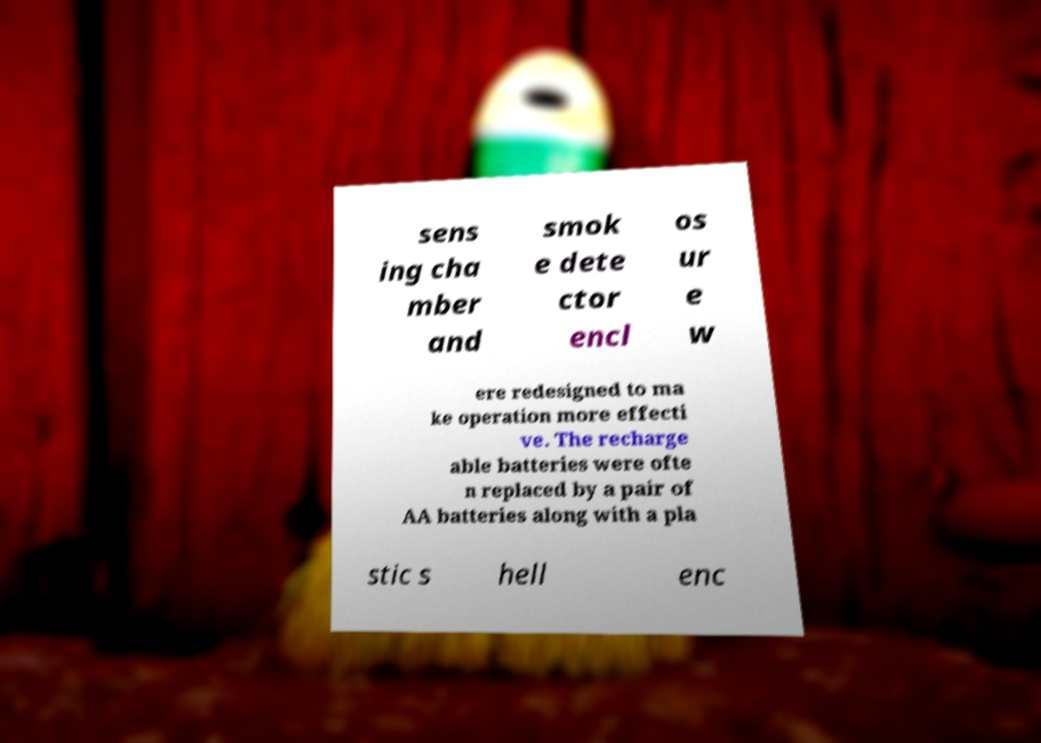For documentation purposes, I need the text within this image transcribed. Could you provide that? sens ing cha mber and smok e dete ctor encl os ur e w ere redesigned to ma ke operation more effecti ve. The recharge able batteries were ofte n replaced by a pair of AA batteries along with a pla stic s hell enc 